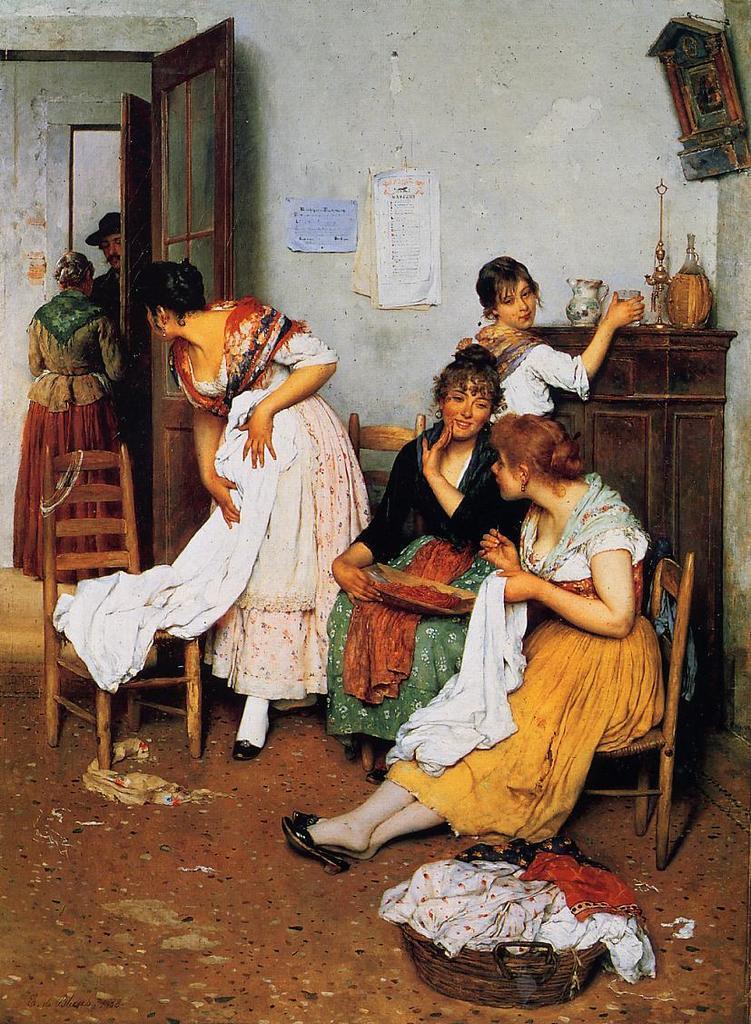Please provide a concise description of this image. In this image there are group of persons standing and sitting. In the front on the ground there is a basket and on the basket there are clothes. In the background there is a door and there are papers hanging on the wall and there is a clock on the wall. In front of the wall there is a cupboard and on the cupboards there are objects which are white and brown in colour and there are empty chairs. 